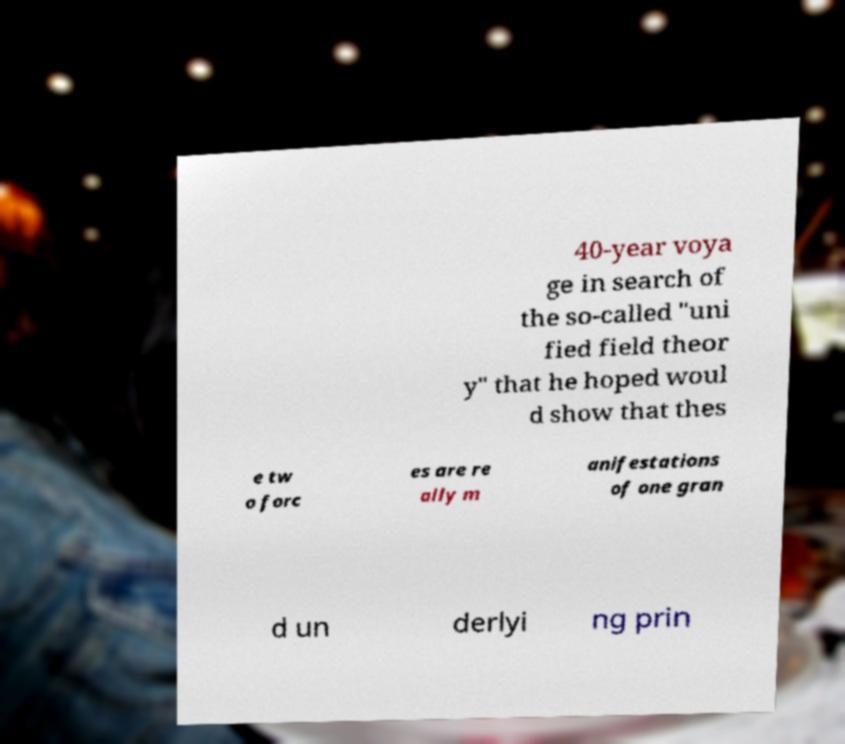I need the written content from this picture converted into text. Can you do that? 40-year voya ge in search of the so-called "uni fied field theor y" that he hoped woul d show that thes e tw o forc es are re ally m anifestations of one gran d un derlyi ng prin 